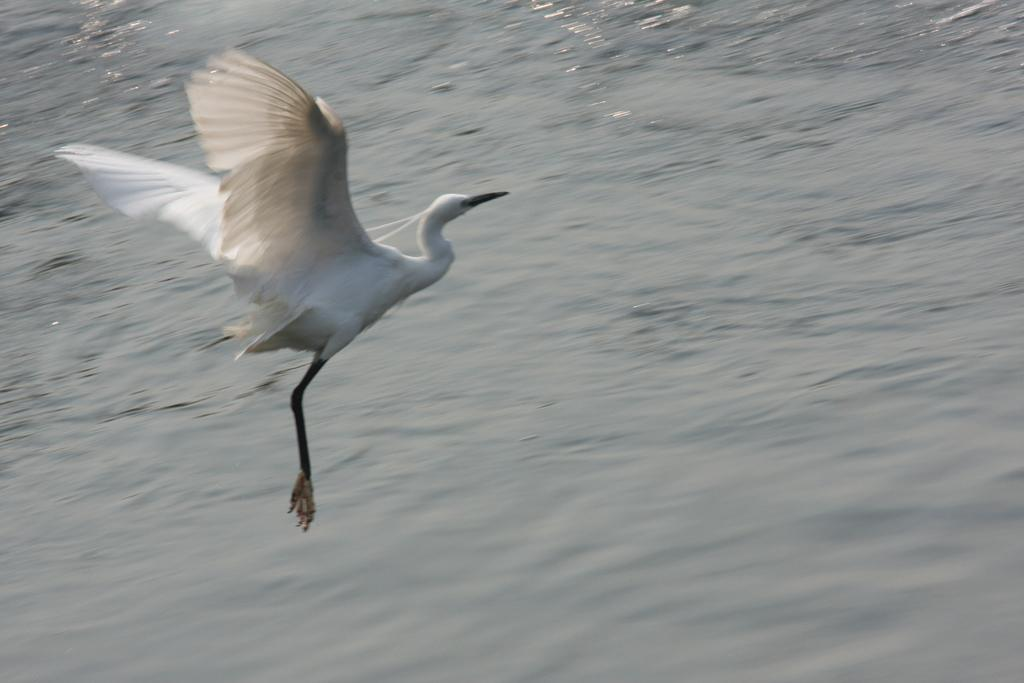What is the bird doing in the image? The bird is flying in the air. What can be seen in the background of the image? There is water visible in the image. How many toes does the scarecrow have in the image? There is no scarecrow present in the image, so it is not possible to determine the number of toes. 